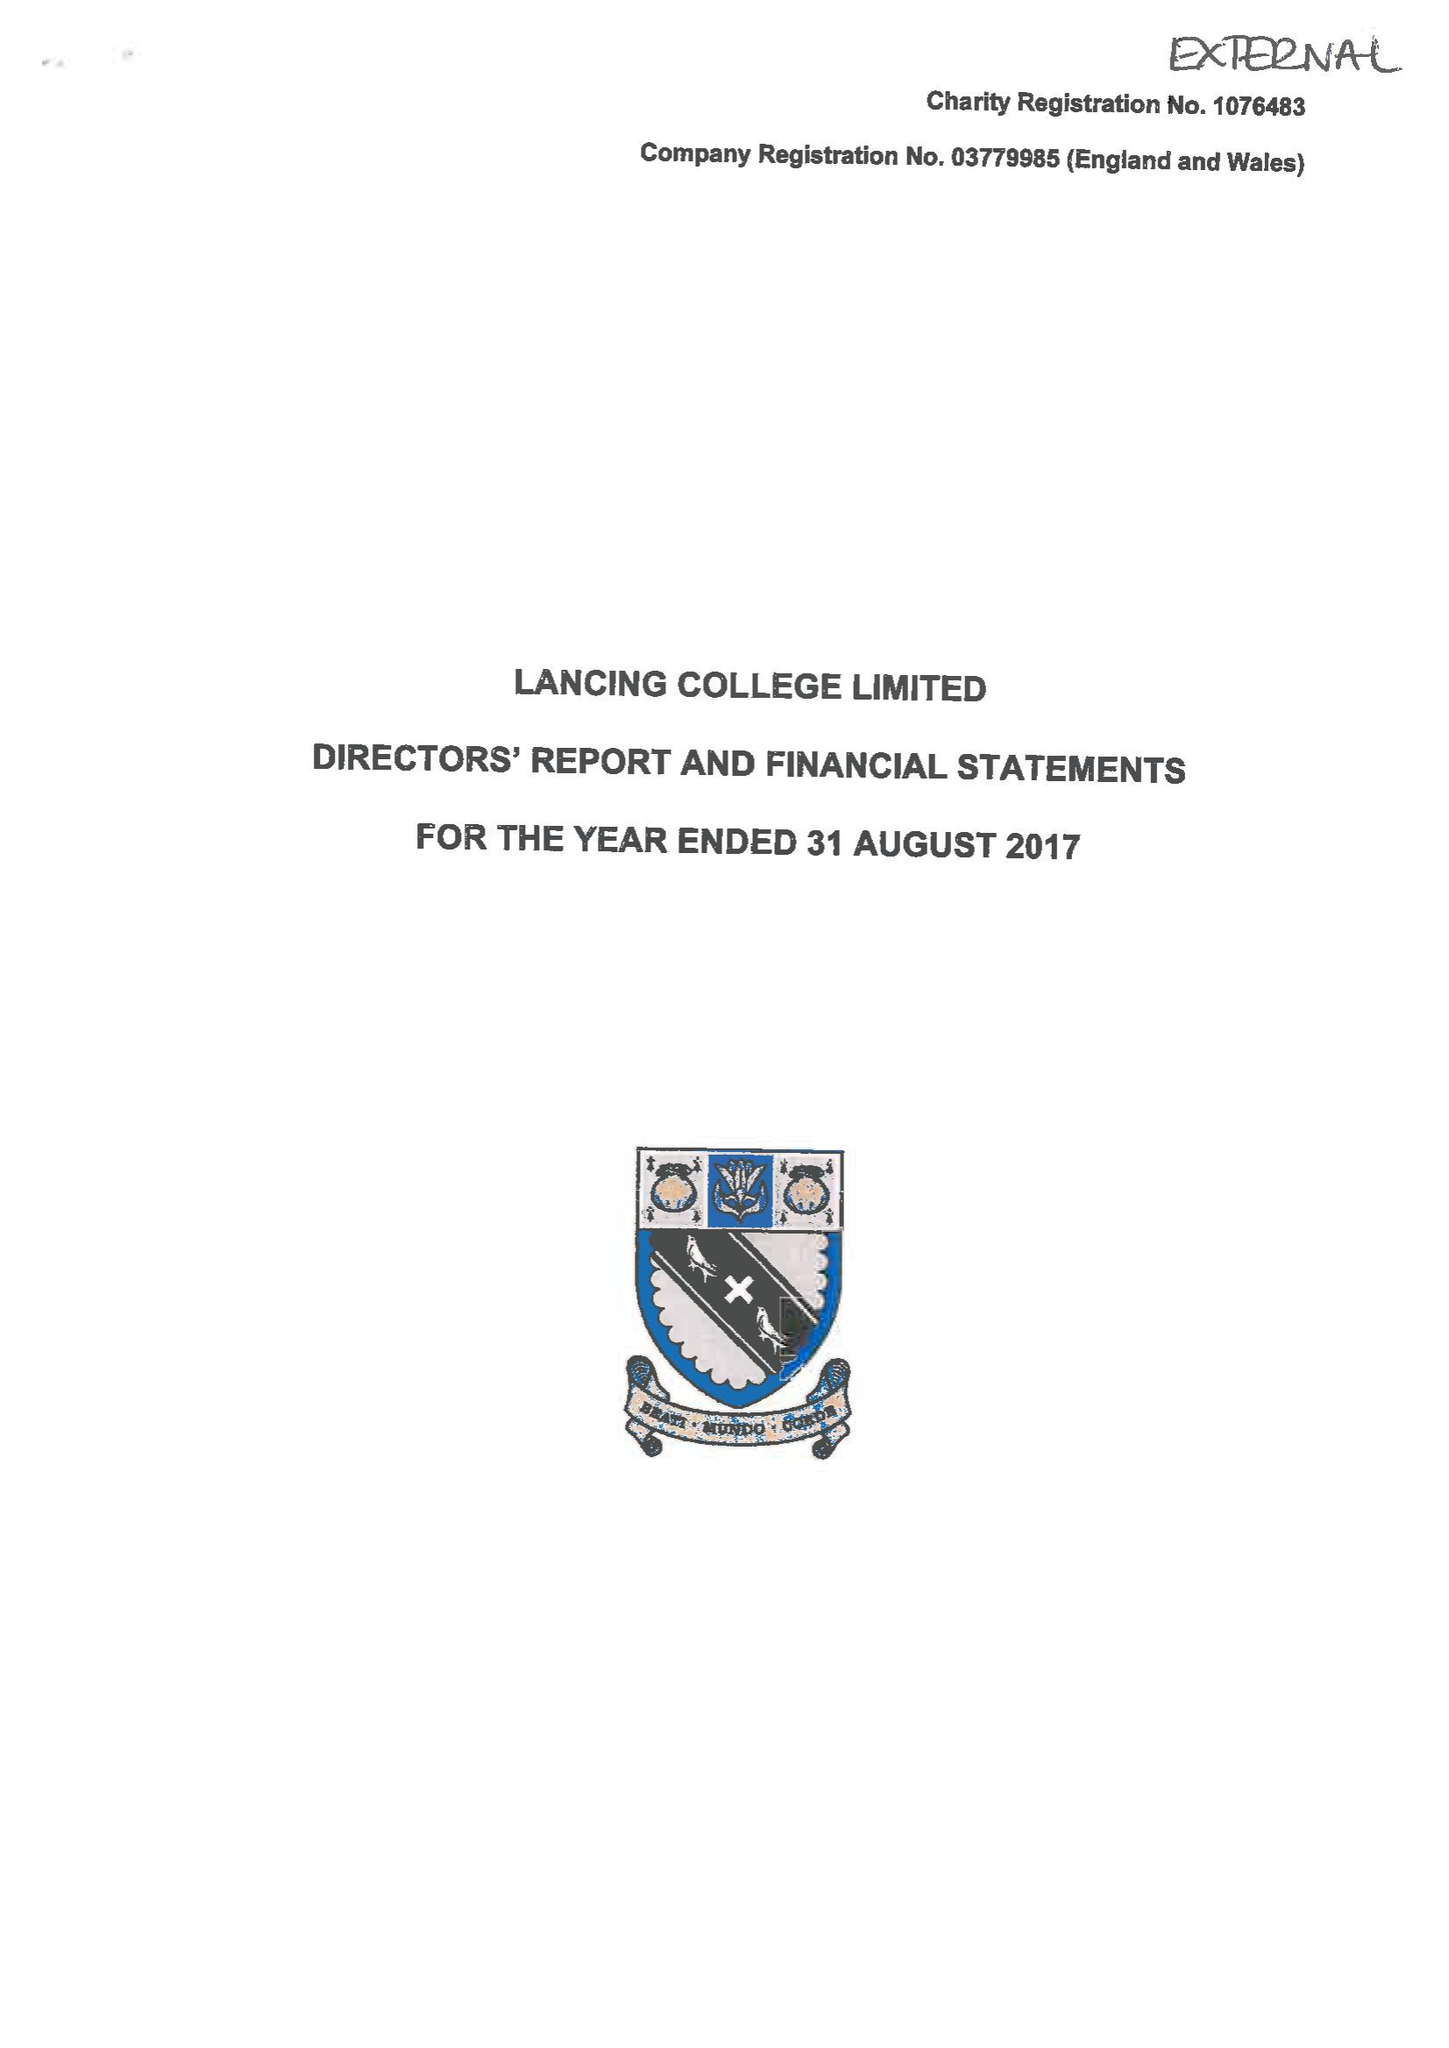What is the value for the charity_number?
Answer the question using a single word or phrase. 1076483 